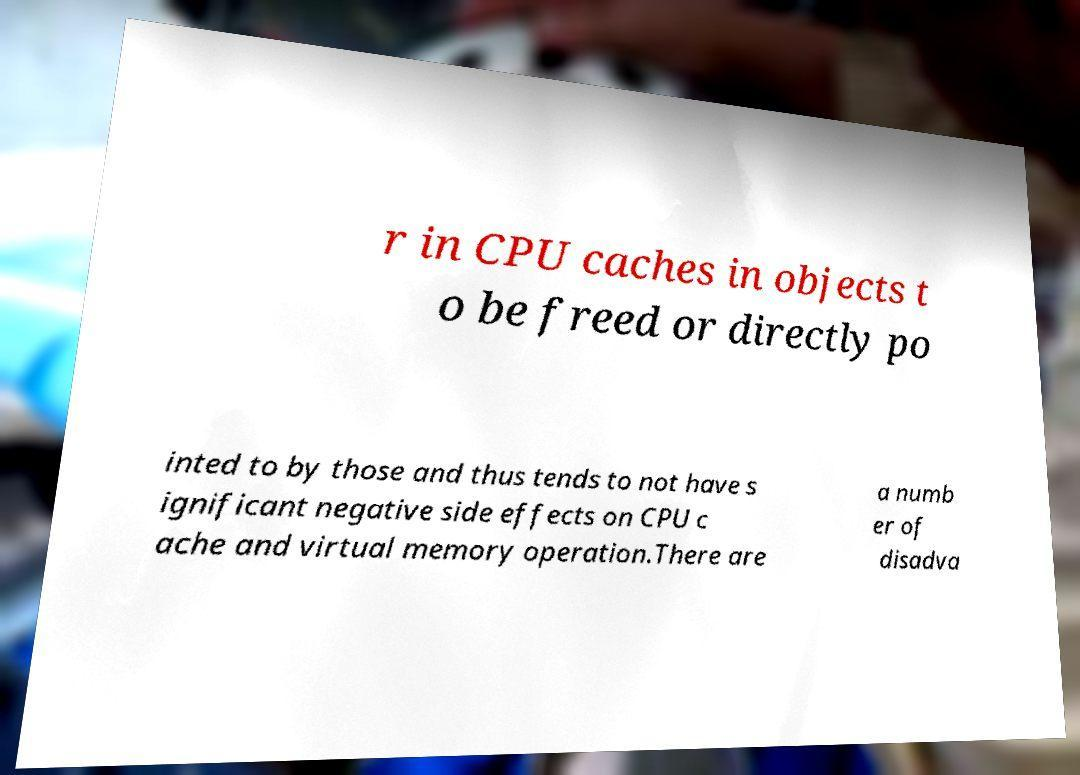Please read and relay the text visible in this image. What does it say? r in CPU caches in objects t o be freed or directly po inted to by those and thus tends to not have s ignificant negative side effects on CPU c ache and virtual memory operation.There are a numb er of disadva 